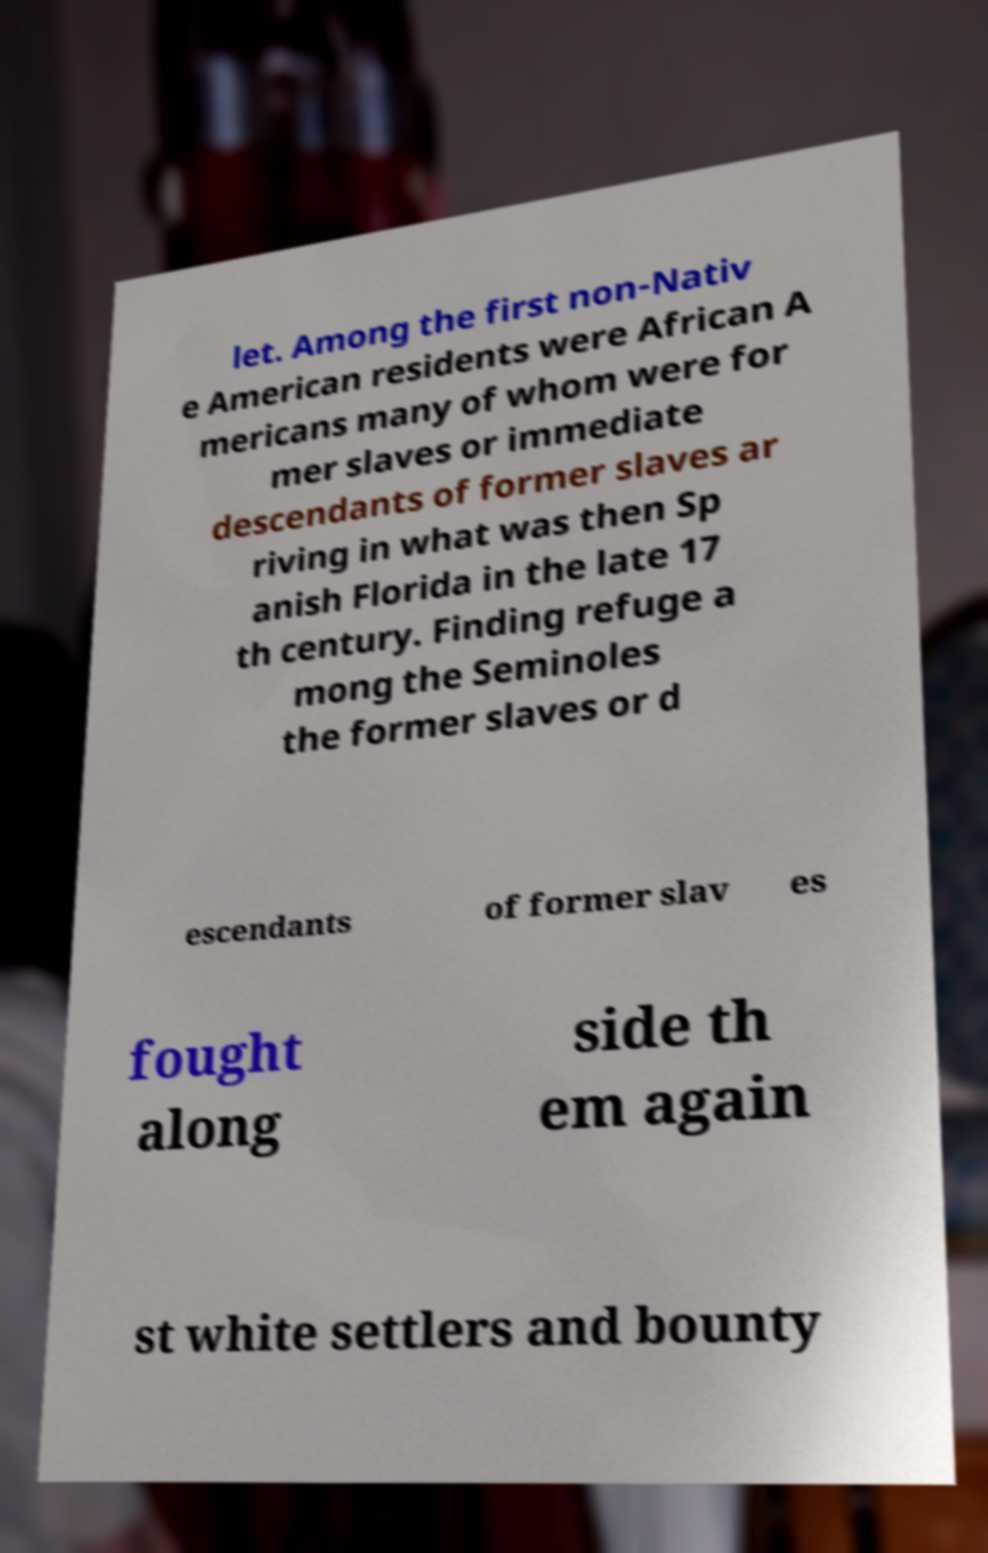For documentation purposes, I need the text within this image transcribed. Could you provide that? let. Among the first non-Nativ e American residents were African A mericans many of whom were for mer slaves or immediate descendants of former slaves ar riving in what was then Sp anish Florida in the late 17 th century. Finding refuge a mong the Seminoles the former slaves or d escendants of former slav es fought along side th em again st white settlers and bounty 